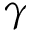<formula> <loc_0><loc_0><loc_500><loc_500>\gamma</formula> 